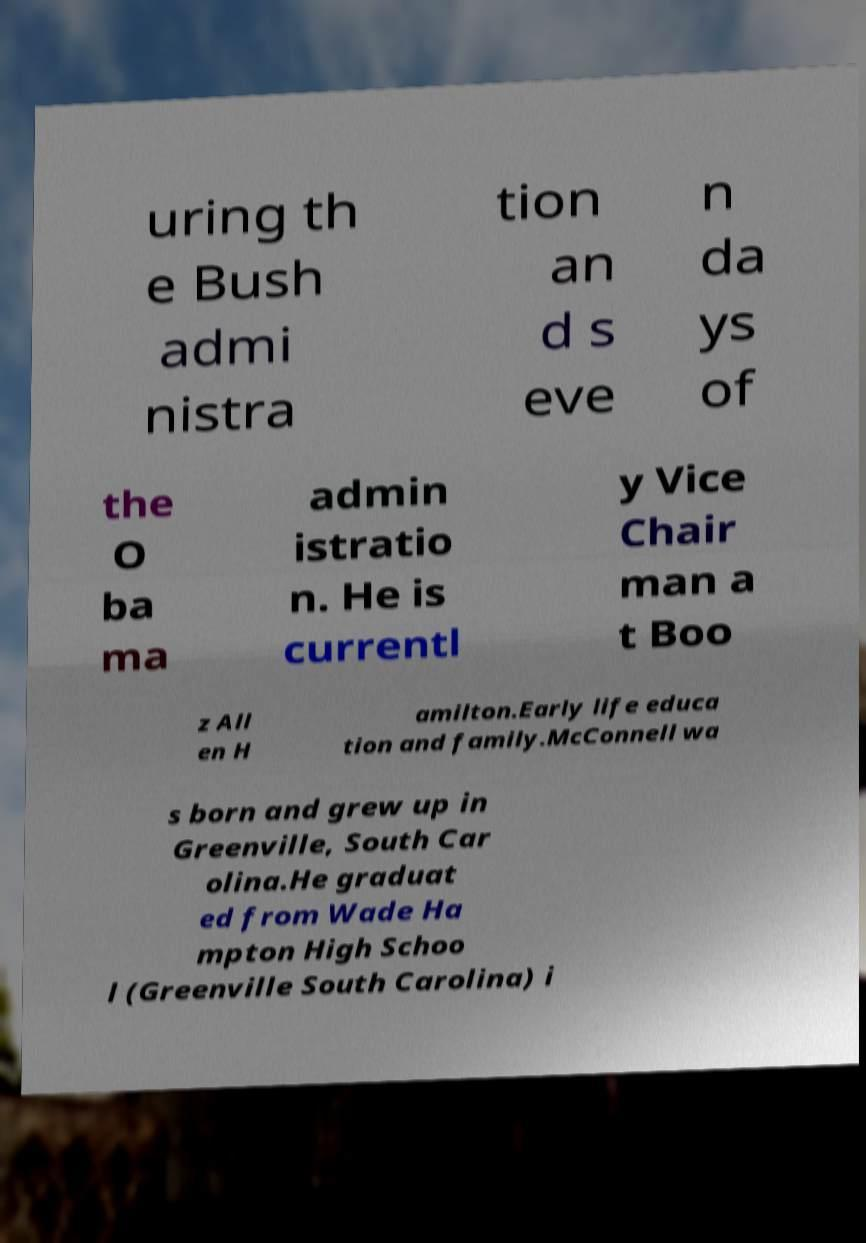Can you read and provide the text displayed in the image?This photo seems to have some interesting text. Can you extract and type it out for me? uring th e Bush admi nistra tion an d s eve n da ys of the O ba ma admin istratio n. He is currentl y Vice Chair man a t Boo z All en H amilton.Early life educa tion and family.McConnell wa s born and grew up in Greenville, South Car olina.He graduat ed from Wade Ha mpton High Schoo l (Greenville South Carolina) i 